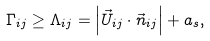<formula> <loc_0><loc_0><loc_500><loc_500>\Gamma _ { i j } \geq \Lambda _ { i j } = \left | \vec { U } _ { i j } \cdot \vec { n } _ { i j } \right | + a _ { s } ,</formula> 